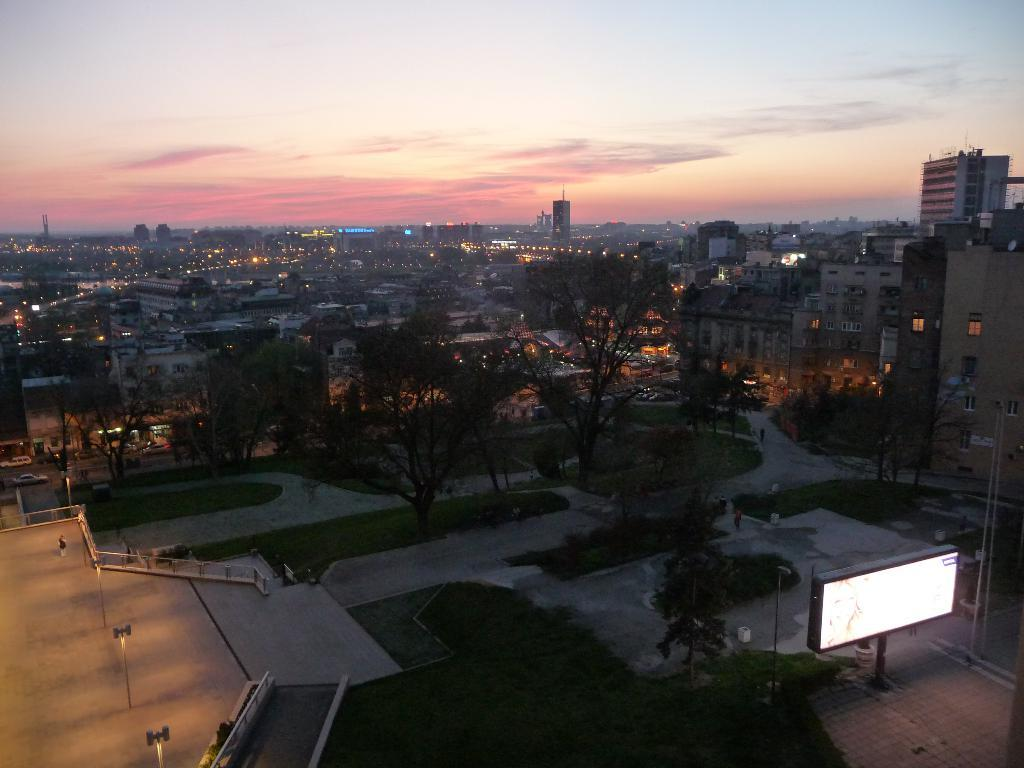What is located in the center of the image? There are trees in the center of the image. What can be seen in the background of the image? There are buildings in the background of the image. What is visible at the top of the image? The sky is visible at the top of the image. Are there any balls or rice visible in the image? No, there are no balls or rice present in the image. Can you see a fan in the image? No, there is no fan visible in the image. 